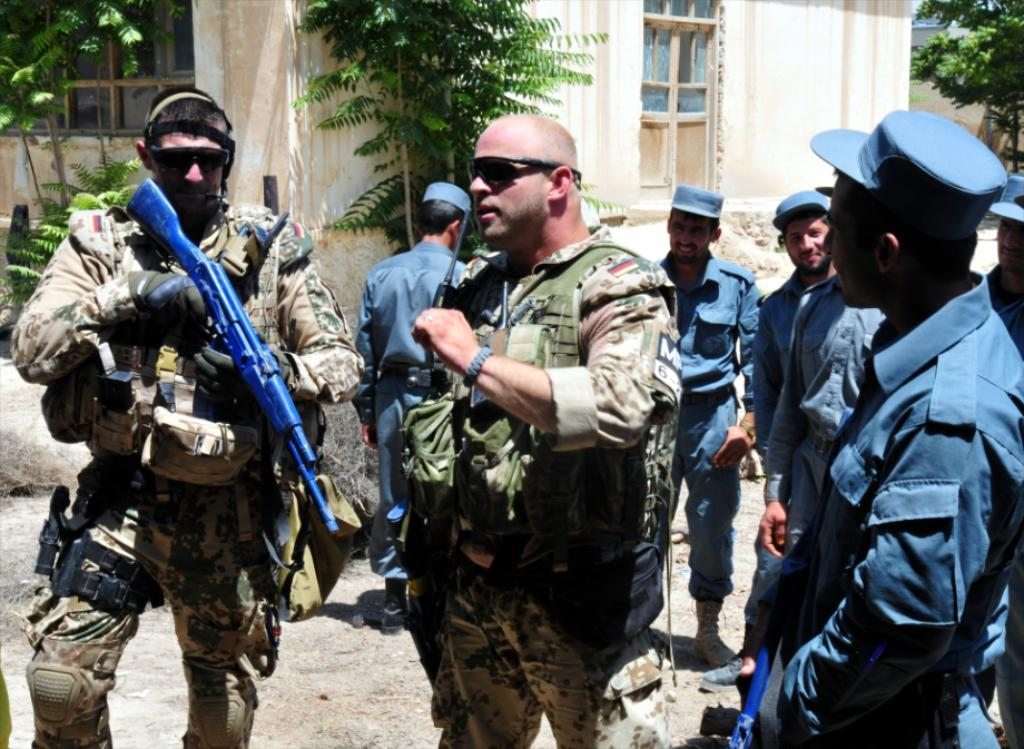How many people are in the image? There is a group of persons standing in the image. Can you describe the man on the left side of the image? The man on the left side of the image is holding a gun. What can be seen in the background of the image? There are trees and buildings in the background of the image. What type of stone is the man biting in the image? There is no stone or biting action present in the image. How many matches are visible in the image? There are no matches present in the image. 